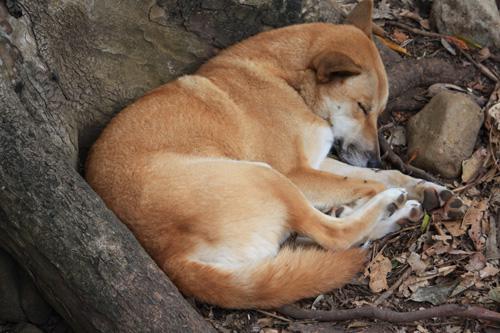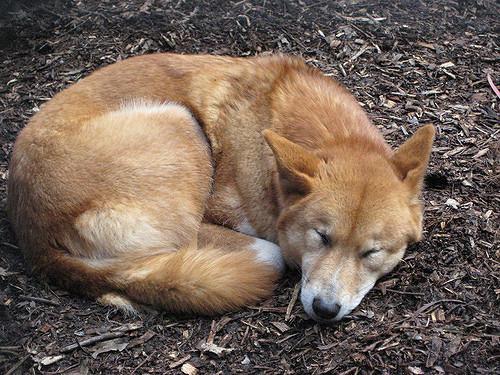The first image is the image on the left, the second image is the image on the right. Considering the images on both sides, is "The left image contains exactly two wild dogs." valid? Answer yes or no. No. The first image is the image on the left, the second image is the image on the right. Assess this claim about the two images: "An image includes an adult dingo that is not lying with its head on the ground.". Correct or not? Answer yes or no. No. 